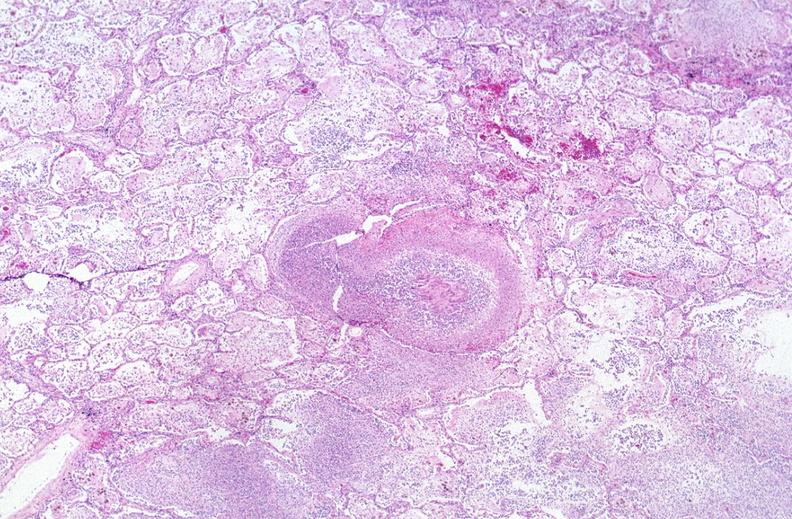does this image show lung, mycobacterium tuberculosis, granulomas and giant cells?
Answer the question using a single word or phrase. Yes 